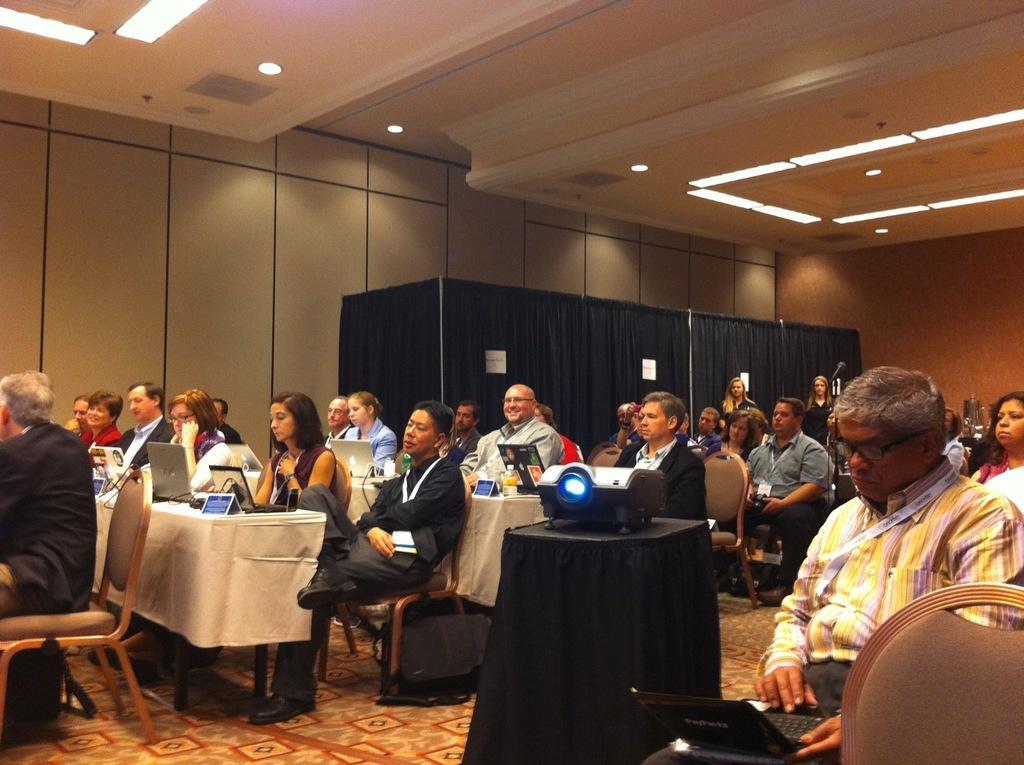Please provide a concise description of this image. There are a group of people who are sitting on chairs. This is a laptop. This is a projector which is placed on table. 